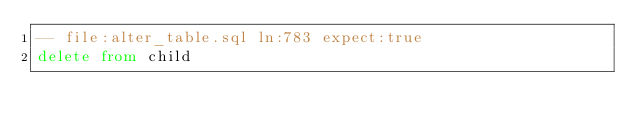Convert code to text. <code><loc_0><loc_0><loc_500><loc_500><_SQL_>-- file:alter_table.sql ln:783 expect:true
delete from child
</code> 